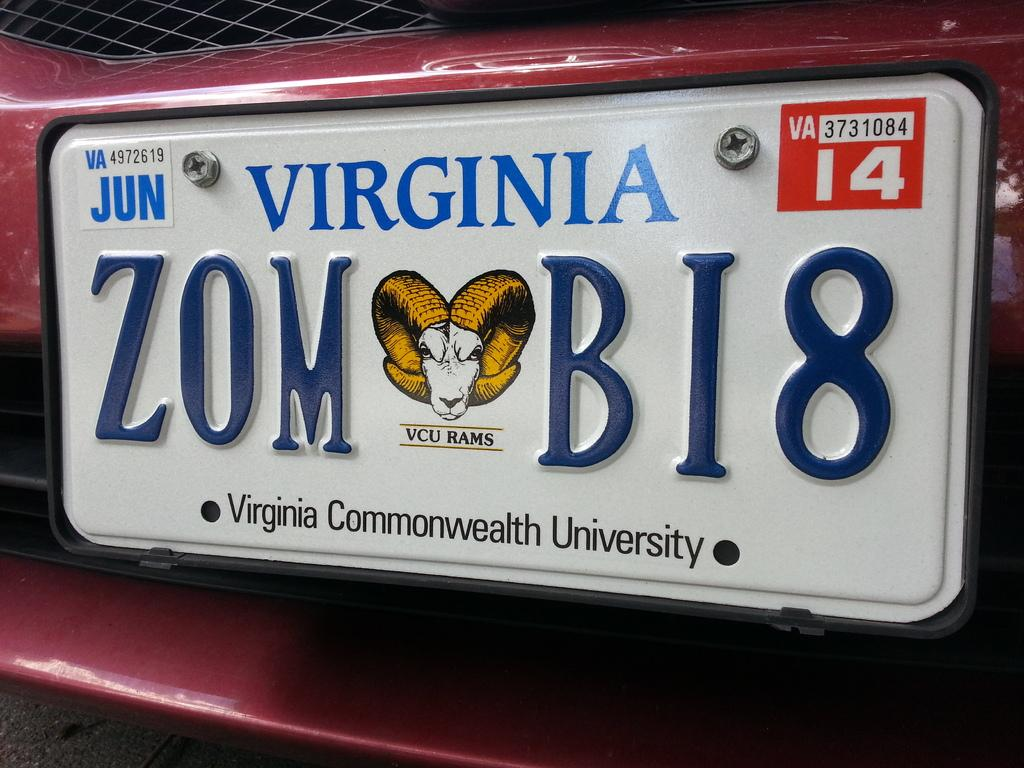<image>
Describe the image concisely. A Virginia license plate reads the numbers and letters ZOM BI8. 